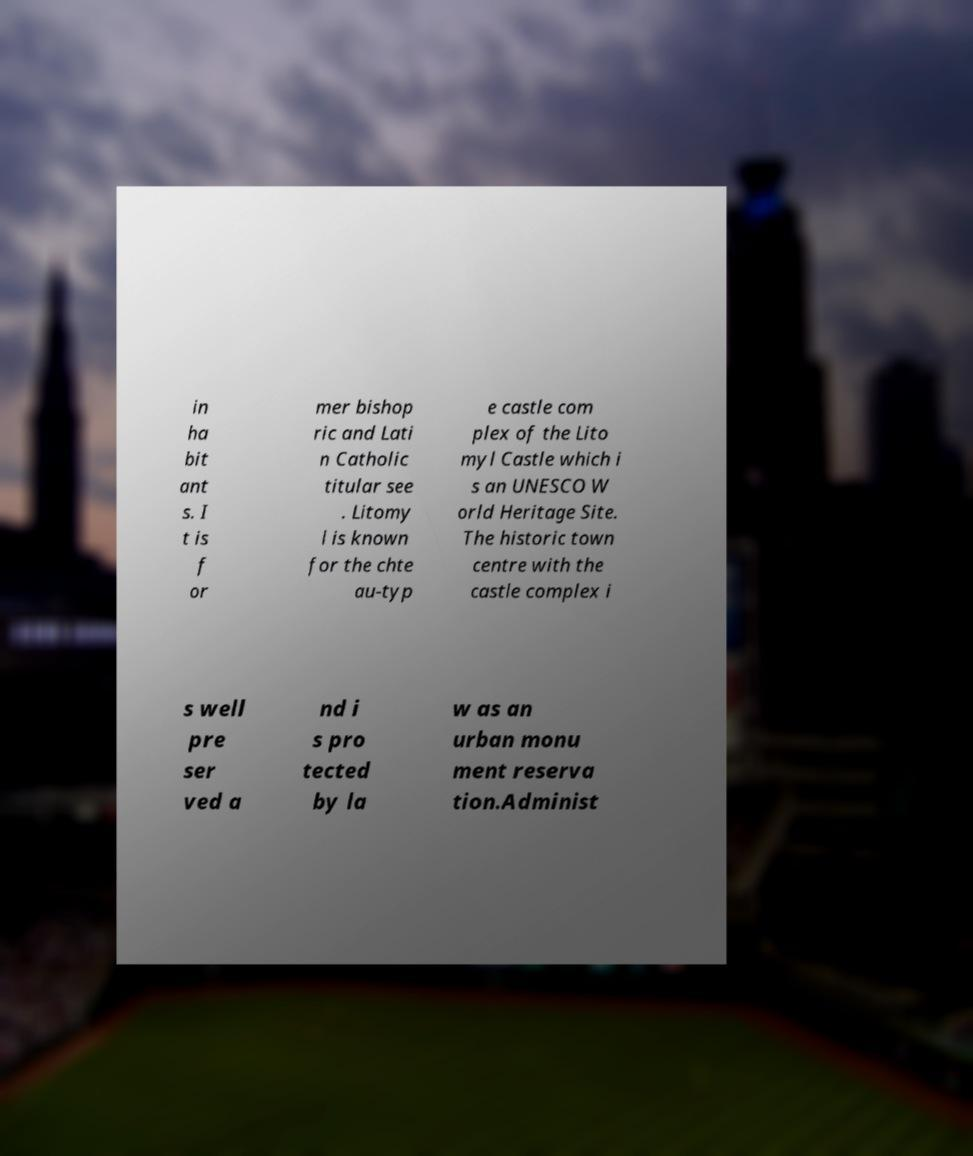I need the written content from this picture converted into text. Can you do that? in ha bit ant s. I t is f or mer bishop ric and Lati n Catholic titular see . Litomy l is known for the chte au-typ e castle com plex of the Lito myl Castle which i s an UNESCO W orld Heritage Site. The historic town centre with the castle complex i s well pre ser ved a nd i s pro tected by la w as an urban monu ment reserva tion.Administ 